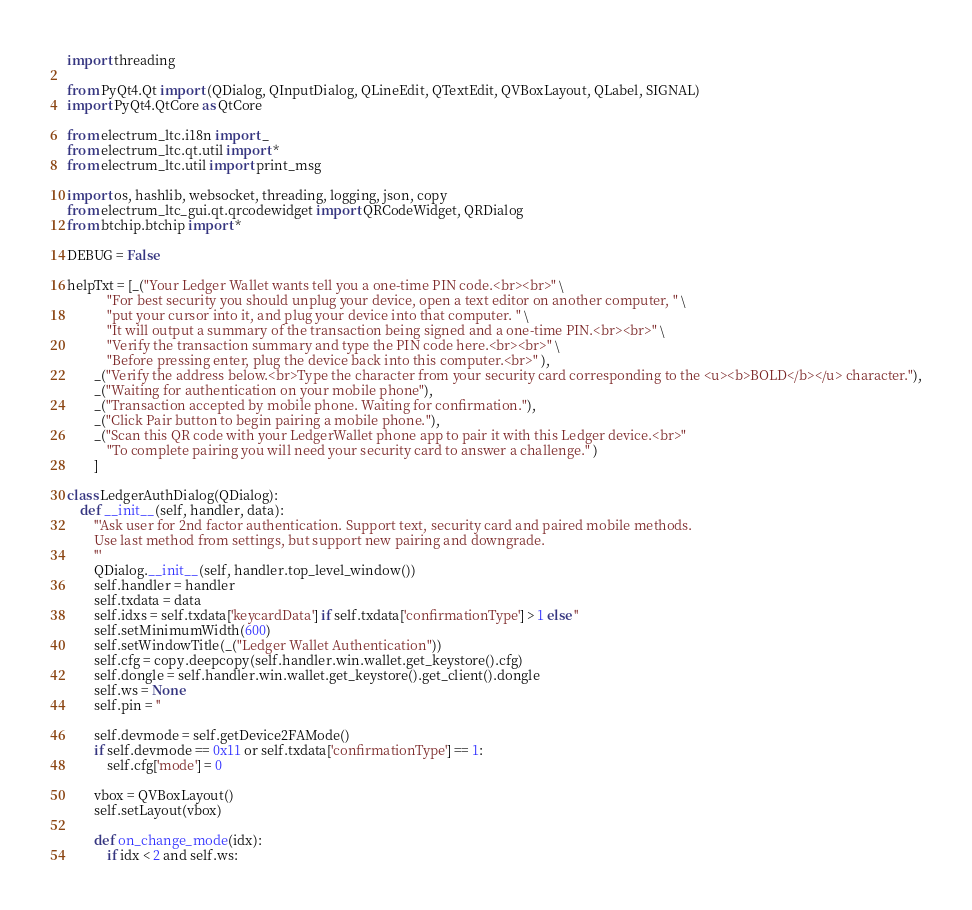Convert code to text. <code><loc_0><loc_0><loc_500><loc_500><_Python_>import threading

from PyQt4.Qt import (QDialog, QInputDialog, QLineEdit, QTextEdit, QVBoxLayout, QLabel, SIGNAL)
import PyQt4.QtCore as QtCore

from electrum_ltc.i18n import _
from electrum_ltc.qt.util import *
from electrum_ltc.util import print_msg

import os, hashlib, websocket, threading, logging, json, copy
from electrum_ltc_gui.qt.qrcodewidget import QRCodeWidget, QRDialog
from btchip.btchip import *

DEBUG = False

helpTxt = [_("Your Ledger Wallet wants tell you a one-time PIN code.<br><br>" \
            "For best security you should unplug your device, open a text editor on another computer, " \
            "put your cursor into it, and plug your device into that computer. " \
            "It will output a summary of the transaction being signed and a one-time PIN.<br><br>" \
            "Verify the transaction summary and type the PIN code here.<br><br>" \
            "Before pressing enter, plug the device back into this computer.<br>" ),
        _("Verify the address below.<br>Type the character from your security card corresponding to the <u><b>BOLD</b></u> character."),
        _("Waiting for authentication on your mobile phone"),
        _("Transaction accepted by mobile phone. Waiting for confirmation."),
        _("Click Pair button to begin pairing a mobile phone."),
        _("Scan this QR code with your LedgerWallet phone app to pair it with this Ledger device.<br>" 
            "To complete pairing you will need your security card to answer a challenge." )
        ]

class LedgerAuthDialog(QDialog):
    def __init__(self, handler, data):
        '''Ask user for 2nd factor authentication. Support text, security card and paired mobile methods.
        Use last method from settings, but support new pairing and downgrade.
        '''
        QDialog.__init__(self, handler.top_level_window())
        self.handler = handler
        self.txdata = data
        self.idxs = self.txdata['keycardData'] if self.txdata['confirmationType'] > 1 else ''
        self.setMinimumWidth(600)
        self.setWindowTitle(_("Ledger Wallet Authentication"))
        self.cfg = copy.deepcopy(self.handler.win.wallet.get_keystore().cfg)
        self.dongle = self.handler.win.wallet.get_keystore().get_client().dongle
        self.ws = None
        self.pin = ''
        
        self.devmode = self.getDevice2FAMode()
        if self.devmode == 0x11 or self.txdata['confirmationType'] == 1:
            self.cfg['mode'] = 0
        
        vbox = QVBoxLayout()
        self.setLayout(vbox)
        
        def on_change_mode(idx):
            if idx < 2 and self.ws:</code> 